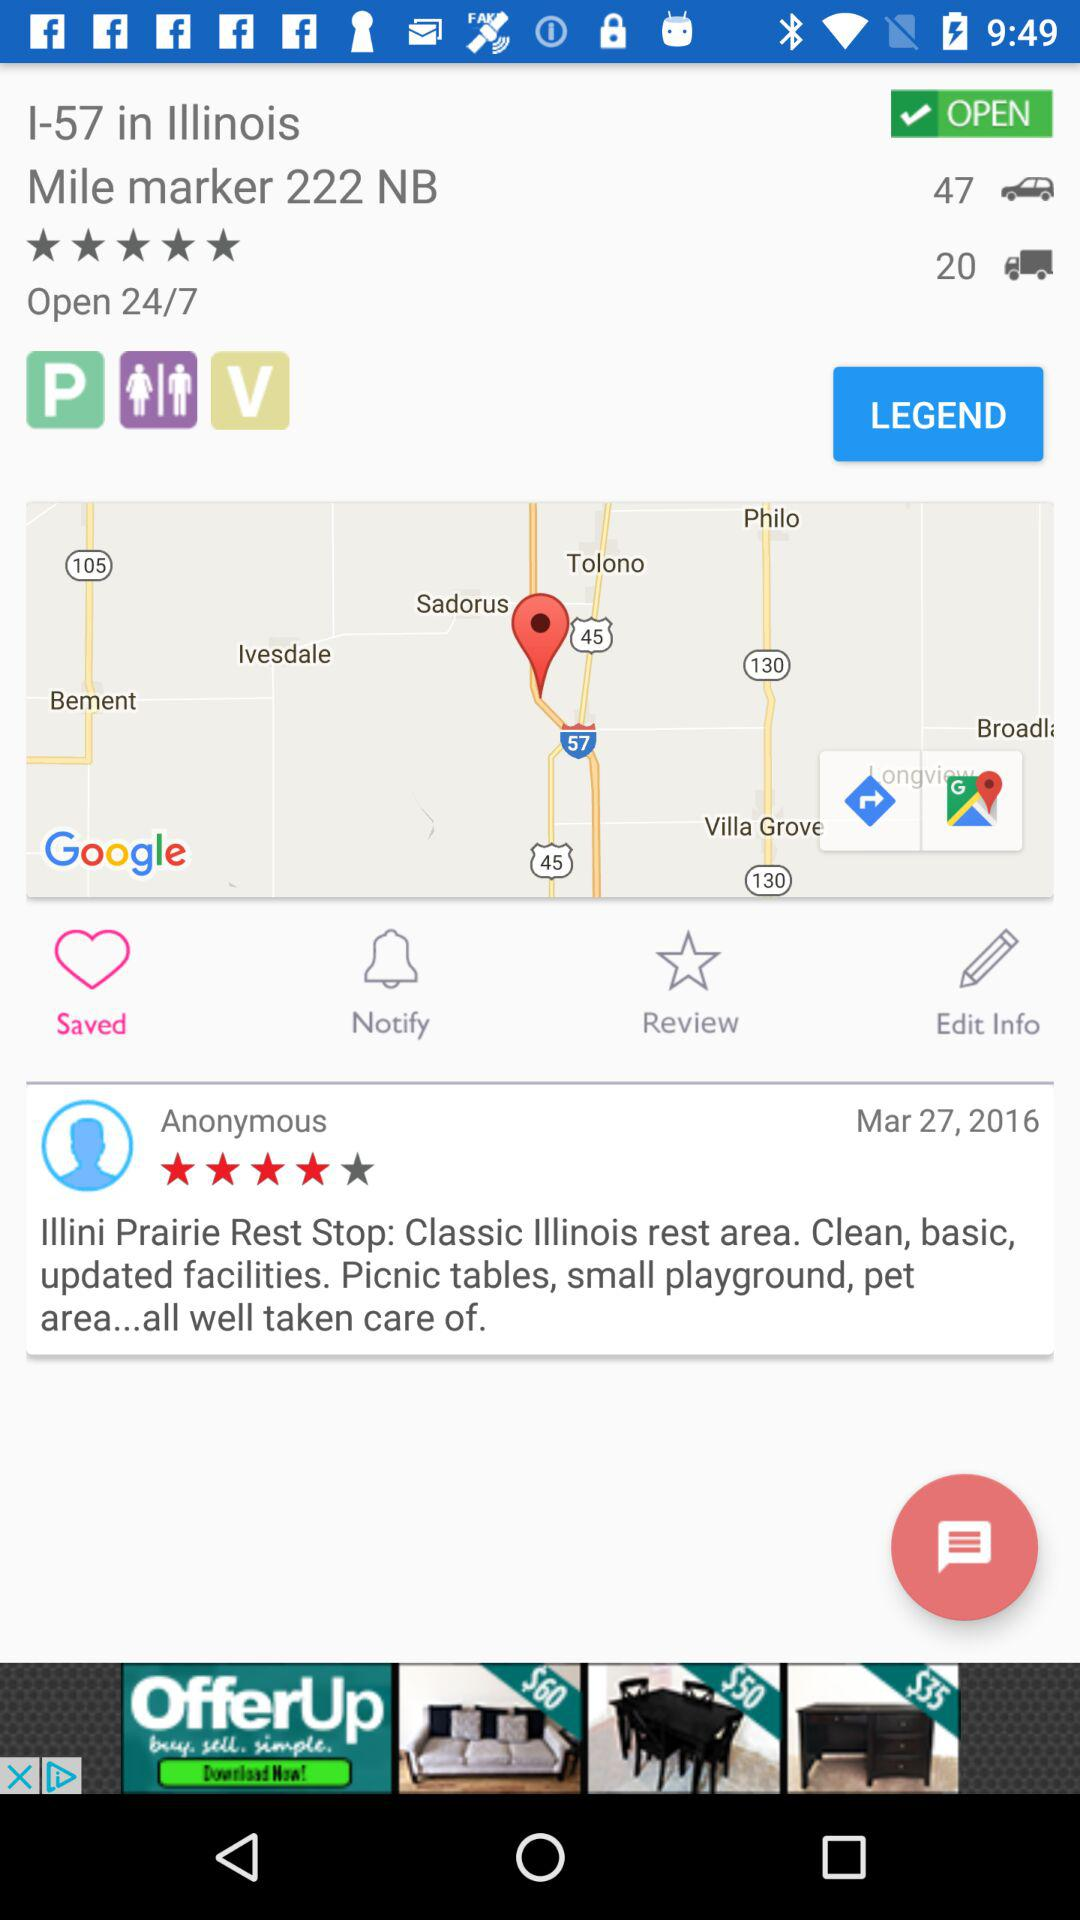What are the timings for opening? It is open 24/7. 